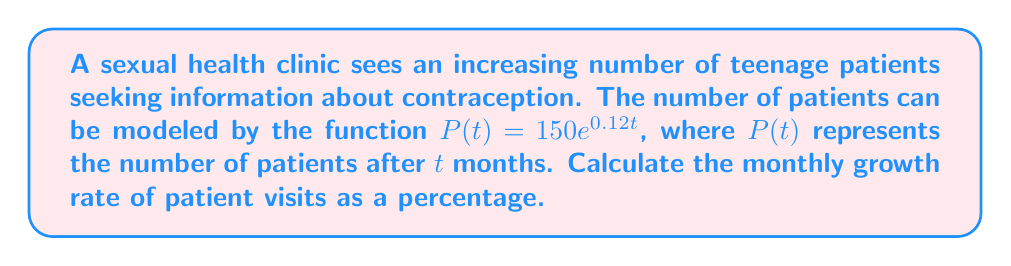Provide a solution to this math problem. To find the monthly growth rate, we need to follow these steps:

1) The general form of an exponential function is:
   $f(t) = ae^{rt}$
   where $r$ is the continuous growth rate.

2) In our function $P(t) = 150e^{0.12t}$, we can identify that $r = 0.12$.

3) To convert the continuous growth rate to a monthly growth rate, we use the formula:
   Monthly rate = $e^r - 1$

4) Substituting our $r$ value:
   Monthly rate = $e^{0.12} - 1$

5) Calculate:
   Monthly rate = $1.1275 - 1 = 0.1275$

6) Convert to a percentage:
   $0.1275 \times 100\% = 12.75\%$

Therefore, the monthly growth rate of patient visits is 12.75%.
Answer: 12.75% 